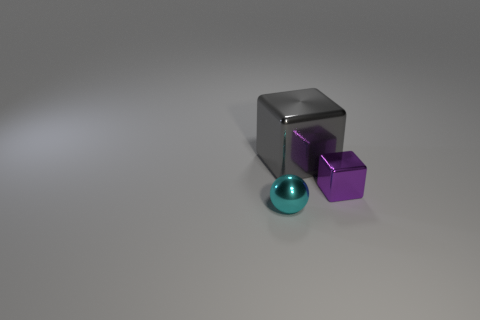Add 2 big cyan shiny blocks. How many objects exist? 5 Subtract all yellow balls. Subtract all brown blocks. How many balls are left? 1 Subtract all blue balls. How many yellow cubes are left? 0 Subtract all big metallic cubes. Subtract all metallic blocks. How many objects are left? 0 Add 1 shiny cubes. How many shiny cubes are left? 3 Add 3 red matte spheres. How many red matte spheres exist? 3 Subtract all purple cubes. How many cubes are left? 1 Subtract 0 red spheres. How many objects are left? 3 Subtract all spheres. How many objects are left? 2 Subtract 1 blocks. How many blocks are left? 1 